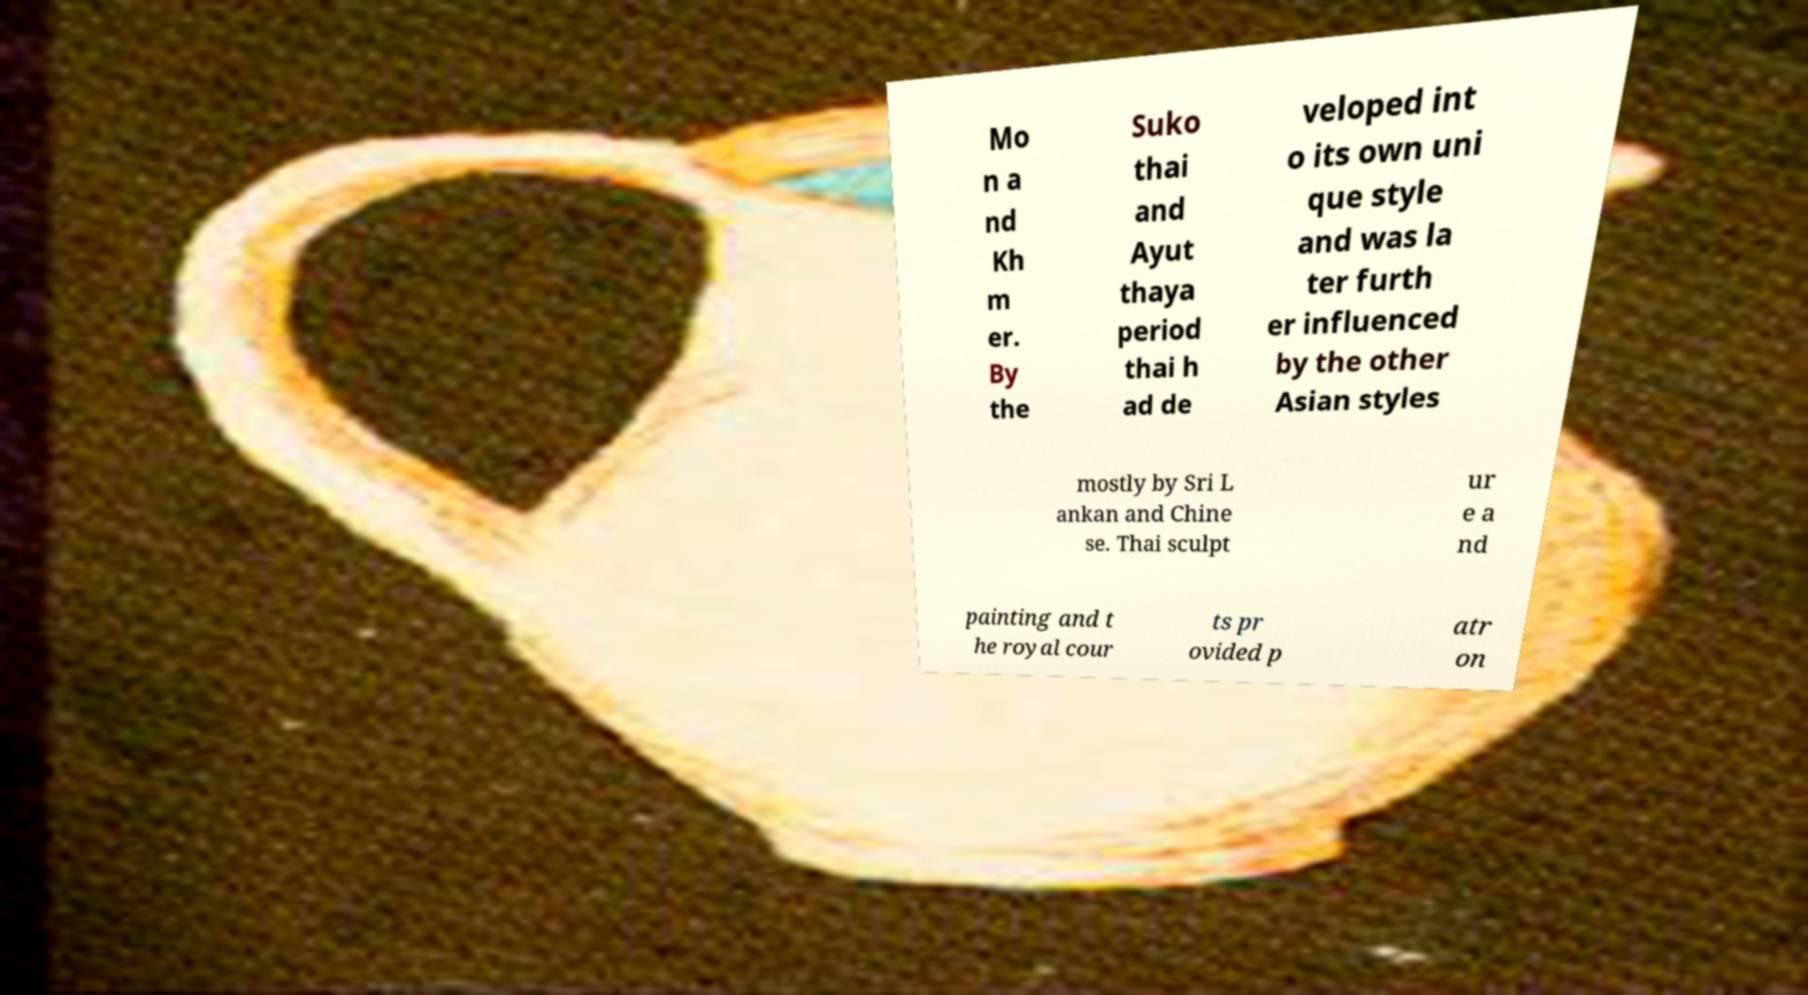There's text embedded in this image that I need extracted. Can you transcribe it verbatim? Mo n a nd Kh m er. By the Suko thai and Ayut thaya period thai h ad de veloped int o its own uni que style and was la ter furth er influenced by the other Asian styles mostly by Sri L ankan and Chine se. Thai sculpt ur e a nd painting and t he royal cour ts pr ovided p atr on 